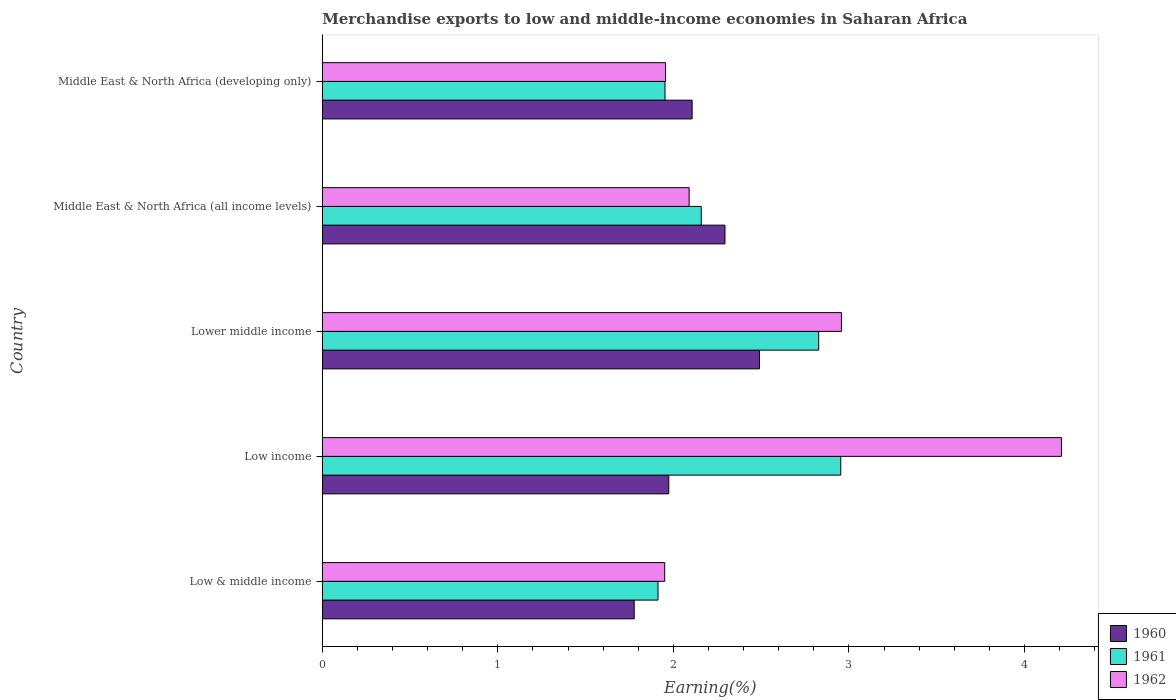How many different coloured bars are there?
Offer a very short reply. 3. Are the number of bars per tick equal to the number of legend labels?
Keep it short and to the point. Yes. Are the number of bars on each tick of the Y-axis equal?
Ensure brevity in your answer.  Yes. How many bars are there on the 5th tick from the top?
Your response must be concise. 3. What is the label of the 3rd group of bars from the top?
Ensure brevity in your answer.  Lower middle income. What is the percentage of amount earned from merchandise exports in 1960 in Middle East & North Africa (all income levels)?
Ensure brevity in your answer.  2.29. Across all countries, what is the maximum percentage of amount earned from merchandise exports in 1961?
Your answer should be very brief. 2.95. Across all countries, what is the minimum percentage of amount earned from merchandise exports in 1960?
Your answer should be very brief. 1.78. In which country was the percentage of amount earned from merchandise exports in 1961 maximum?
Provide a short and direct response. Low income. In which country was the percentage of amount earned from merchandise exports in 1962 minimum?
Provide a succinct answer. Low & middle income. What is the total percentage of amount earned from merchandise exports in 1960 in the graph?
Keep it short and to the point. 10.64. What is the difference between the percentage of amount earned from merchandise exports in 1960 in Low income and that in Middle East & North Africa (all income levels)?
Your response must be concise. -0.32. What is the difference between the percentage of amount earned from merchandise exports in 1962 in Lower middle income and the percentage of amount earned from merchandise exports in 1960 in Middle East & North Africa (developing only)?
Make the answer very short. 0.85. What is the average percentage of amount earned from merchandise exports in 1960 per country?
Make the answer very short. 2.13. What is the difference between the percentage of amount earned from merchandise exports in 1961 and percentage of amount earned from merchandise exports in 1962 in Low income?
Your answer should be very brief. -1.26. What is the ratio of the percentage of amount earned from merchandise exports in 1961 in Low income to that in Lower middle income?
Provide a short and direct response. 1.04. Is the difference between the percentage of amount earned from merchandise exports in 1961 in Middle East & North Africa (all income levels) and Middle East & North Africa (developing only) greater than the difference between the percentage of amount earned from merchandise exports in 1962 in Middle East & North Africa (all income levels) and Middle East & North Africa (developing only)?
Your answer should be compact. Yes. What is the difference between the highest and the second highest percentage of amount earned from merchandise exports in 1960?
Offer a terse response. 0.2. What is the difference between the highest and the lowest percentage of amount earned from merchandise exports in 1961?
Offer a very short reply. 1.04. In how many countries, is the percentage of amount earned from merchandise exports in 1960 greater than the average percentage of amount earned from merchandise exports in 1960 taken over all countries?
Provide a short and direct response. 2. Is the sum of the percentage of amount earned from merchandise exports in 1962 in Lower middle income and Middle East & North Africa (all income levels) greater than the maximum percentage of amount earned from merchandise exports in 1961 across all countries?
Ensure brevity in your answer.  Yes. What does the 3rd bar from the top in Middle East & North Africa (all income levels) represents?
Keep it short and to the point. 1960. What does the 3rd bar from the bottom in Middle East & North Africa (developing only) represents?
Keep it short and to the point. 1962. How many bars are there?
Provide a succinct answer. 15. What is the difference between two consecutive major ticks on the X-axis?
Your answer should be very brief. 1. How are the legend labels stacked?
Offer a terse response. Vertical. What is the title of the graph?
Give a very brief answer. Merchandise exports to low and middle-income economies in Saharan Africa. Does "1970" appear as one of the legend labels in the graph?
Provide a succinct answer. No. What is the label or title of the X-axis?
Provide a short and direct response. Earning(%). What is the label or title of the Y-axis?
Your response must be concise. Country. What is the Earning(%) of 1960 in Low & middle income?
Keep it short and to the point. 1.78. What is the Earning(%) of 1961 in Low & middle income?
Your answer should be very brief. 1.91. What is the Earning(%) of 1962 in Low & middle income?
Your response must be concise. 1.95. What is the Earning(%) in 1960 in Low income?
Ensure brevity in your answer.  1.97. What is the Earning(%) of 1961 in Low income?
Give a very brief answer. 2.95. What is the Earning(%) of 1962 in Low income?
Your response must be concise. 4.21. What is the Earning(%) in 1960 in Lower middle income?
Give a very brief answer. 2.49. What is the Earning(%) in 1961 in Lower middle income?
Give a very brief answer. 2.83. What is the Earning(%) in 1962 in Lower middle income?
Your answer should be very brief. 2.96. What is the Earning(%) in 1960 in Middle East & North Africa (all income levels)?
Keep it short and to the point. 2.29. What is the Earning(%) of 1961 in Middle East & North Africa (all income levels)?
Your answer should be very brief. 2.16. What is the Earning(%) of 1962 in Middle East & North Africa (all income levels)?
Provide a short and direct response. 2.09. What is the Earning(%) of 1960 in Middle East & North Africa (developing only)?
Give a very brief answer. 2.11. What is the Earning(%) of 1961 in Middle East & North Africa (developing only)?
Offer a terse response. 1.95. What is the Earning(%) in 1962 in Middle East & North Africa (developing only)?
Provide a succinct answer. 1.96. Across all countries, what is the maximum Earning(%) of 1960?
Give a very brief answer. 2.49. Across all countries, what is the maximum Earning(%) of 1961?
Ensure brevity in your answer.  2.95. Across all countries, what is the maximum Earning(%) of 1962?
Keep it short and to the point. 4.21. Across all countries, what is the minimum Earning(%) of 1960?
Offer a very short reply. 1.78. Across all countries, what is the minimum Earning(%) in 1961?
Keep it short and to the point. 1.91. Across all countries, what is the minimum Earning(%) in 1962?
Your answer should be very brief. 1.95. What is the total Earning(%) in 1960 in the graph?
Ensure brevity in your answer.  10.64. What is the total Earning(%) of 1961 in the graph?
Offer a terse response. 11.8. What is the total Earning(%) in 1962 in the graph?
Give a very brief answer. 13.16. What is the difference between the Earning(%) of 1960 in Low & middle income and that in Low income?
Your response must be concise. -0.2. What is the difference between the Earning(%) in 1961 in Low & middle income and that in Low income?
Provide a succinct answer. -1.04. What is the difference between the Earning(%) in 1962 in Low & middle income and that in Low income?
Offer a terse response. -2.26. What is the difference between the Earning(%) of 1960 in Low & middle income and that in Lower middle income?
Provide a succinct answer. -0.71. What is the difference between the Earning(%) of 1961 in Low & middle income and that in Lower middle income?
Give a very brief answer. -0.92. What is the difference between the Earning(%) of 1962 in Low & middle income and that in Lower middle income?
Offer a very short reply. -1.01. What is the difference between the Earning(%) in 1960 in Low & middle income and that in Middle East & North Africa (all income levels)?
Ensure brevity in your answer.  -0.52. What is the difference between the Earning(%) of 1961 in Low & middle income and that in Middle East & North Africa (all income levels)?
Make the answer very short. -0.25. What is the difference between the Earning(%) in 1962 in Low & middle income and that in Middle East & North Africa (all income levels)?
Offer a very short reply. -0.14. What is the difference between the Earning(%) in 1960 in Low & middle income and that in Middle East & North Africa (developing only)?
Offer a very short reply. -0.33. What is the difference between the Earning(%) of 1961 in Low & middle income and that in Middle East & North Africa (developing only)?
Offer a very short reply. -0.04. What is the difference between the Earning(%) in 1962 in Low & middle income and that in Middle East & North Africa (developing only)?
Your answer should be compact. -0. What is the difference between the Earning(%) in 1960 in Low income and that in Lower middle income?
Provide a short and direct response. -0.52. What is the difference between the Earning(%) in 1961 in Low income and that in Lower middle income?
Your response must be concise. 0.13. What is the difference between the Earning(%) in 1962 in Low income and that in Lower middle income?
Your answer should be very brief. 1.25. What is the difference between the Earning(%) of 1960 in Low income and that in Middle East & North Africa (all income levels)?
Your answer should be very brief. -0.32. What is the difference between the Earning(%) in 1961 in Low income and that in Middle East & North Africa (all income levels)?
Give a very brief answer. 0.79. What is the difference between the Earning(%) of 1962 in Low income and that in Middle East & North Africa (all income levels)?
Provide a succinct answer. 2.12. What is the difference between the Earning(%) of 1960 in Low income and that in Middle East & North Africa (developing only)?
Keep it short and to the point. -0.13. What is the difference between the Earning(%) of 1961 in Low income and that in Middle East & North Africa (developing only)?
Provide a succinct answer. 1. What is the difference between the Earning(%) in 1962 in Low income and that in Middle East & North Africa (developing only)?
Offer a very short reply. 2.26. What is the difference between the Earning(%) of 1960 in Lower middle income and that in Middle East & North Africa (all income levels)?
Keep it short and to the point. 0.2. What is the difference between the Earning(%) in 1961 in Lower middle income and that in Middle East & North Africa (all income levels)?
Provide a succinct answer. 0.67. What is the difference between the Earning(%) of 1962 in Lower middle income and that in Middle East & North Africa (all income levels)?
Your answer should be very brief. 0.87. What is the difference between the Earning(%) of 1960 in Lower middle income and that in Middle East & North Africa (developing only)?
Your answer should be very brief. 0.38. What is the difference between the Earning(%) of 1961 in Lower middle income and that in Middle East & North Africa (developing only)?
Offer a very short reply. 0.88. What is the difference between the Earning(%) of 1960 in Middle East & North Africa (all income levels) and that in Middle East & North Africa (developing only)?
Offer a very short reply. 0.19. What is the difference between the Earning(%) of 1961 in Middle East & North Africa (all income levels) and that in Middle East & North Africa (developing only)?
Provide a short and direct response. 0.21. What is the difference between the Earning(%) in 1962 in Middle East & North Africa (all income levels) and that in Middle East & North Africa (developing only)?
Give a very brief answer. 0.13. What is the difference between the Earning(%) of 1960 in Low & middle income and the Earning(%) of 1961 in Low income?
Make the answer very short. -1.18. What is the difference between the Earning(%) of 1960 in Low & middle income and the Earning(%) of 1962 in Low income?
Ensure brevity in your answer.  -2.43. What is the difference between the Earning(%) in 1961 in Low & middle income and the Earning(%) in 1962 in Low income?
Make the answer very short. -2.3. What is the difference between the Earning(%) in 1960 in Low & middle income and the Earning(%) in 1961 in Lower middle income?
Offer a very short reply. -1.05. What is the difference between the Earning(%) of 1960 in Low & middle income and the Earning(%) of 1962 in Lower middle income?
Ensure brevity in your answer.  -1.18. What is the difference between the Earning(%) in 1961 in Low & middle income and the Earning(%) in 1962 in Lower middle income?
Make the answer very short. -1.05. What is the difference between the Earning(%) of 1960 in Low & middle income and the Earning(%) of 1961 in Middle East & North Africa (all income levels)?
Keep it short and to the point. -0.38. What is the difference between the Earning(%) of 1960 in Low & middle income and the Earning(%) of 1962 in Middle East & North Africa (all income levels)?
Offer a very short reply. -0.31. What is the difference between the Earning(%) in 1961 in Low & middle income and the Earning(%) in 1962 in Middle East & North Africa (all income levels)?
Your response must be concise. -0.18. What is the difference between the Earning(%) of 1960 in Low & middle income and the Earning(%) of 1961 in Middle East & North Africa (developing only)?
Offer a terse response. -0.18. What is the difference between the Earning(%) of 1960 in Low & middle income and the Earning(%) of 1962 in Middle East & North Africa (developing only)?
Your answer should be very brief. -0.18. What is the difference between the Earning(%) in 1961 in Low & middle income and the Earning(%) in 1962 in Middle East & North Africa (developing only)?
Give a very brief answer. -0.04. What is the difference between the Earning(%) of 1960 in Low income and the Earning(%) of 1961 in Lower middle income?
Keep it short and to the point. -0.85. What is the difference between the Earning(%) of 1960 in Low income and the Earning(%) of 1962 in Lower middle income?
Offer a very short reply. -0.98. What is the difference between the Earning(%) in 1961 in Low income and the Earning(%) in 1962 in Lower middle income?
Make the answer very short. -0. What is the difference between the Earning(%) of 1960 in Low income and the Earning(%) of 1961 in Middle East & North Africa (all income levels)?
Make the answer very short. -0.18. What is the difference between the Earning(%) of 1960 in Low income and the Earning(%) of 1962 in Middle East & North Africa (all income levels)?
Offer a very short reply. -0.12. What is the difference between the Earning(%) of 1961 in Low income and the Earning(%) of 1962 in Middle East & North Africa (all income levels)?
Make the answer very short. 0.86. What is the difference between the Earning(%) of 1960 in Low income and the Earning(%) of 1961 in Middle East & North Africa (developing only)?
Offer a very short reply. 0.02. What is the difference between the Earning(%) in 1960 in Low income and the Earning(%) in 1962 in Middle East & North Africa (developing only)?
Keep it short and to the point. 0.02. What is the difference between the Earning(%) of 1960 in Lower middle income and the Earning(%) of 1961 in Middle East & North Africa (all income levels)?
Make the answer very short. 0.33. What is the difference between the Earning(%) in 1960 in Lower middle income and the Earning(%) in 1962 in Middle East & North Africa (all income levels)?
Ensure brevity in your answer.  0.4. What is the difference between the Earning(%) in 1961 in Lower middle income and the Earning(%) in 1962 in Middle East & North Africa (all income levels)?
Keep it short and to the point. 0.74. What is the difference between the Earning(%) of 1960 in Lower middle income and the Earning(%) of 1961 in Middle East & North Africa (developing only)?
Offer a terse response. 0.54. What is the difference between the Earning(%) in 1960 in Lower middle income and the Earning(%) in 1962 in Middle East & North Africa (developing only)?
Provide a short and direct response. 0.54. What is the difference between the Earning(%) of 1961 in Lower middle income and the Earning(%) of 1962 in Middle East & North Africa (developing only)?
Your answer should be compact. 0.87. What is the difference between the Earning(%) in 1960 in Middle East & North Africa (all income levels) and the Earning(%) in 1961 in Middle East & North Africa (developing only)?
Give a very brief answer. 0.34. What is the difference between the Earning(%) in 1960 in Middle East & North Africa (all income levels) and the Earning(%) in 1962 in Middle East & North Africa (developing only)?
Make the answer very short. 0.34. What is the difference between the Earning(%) of 1961 in Middle East & North Africa (all income levels) and the Earning(%) of 1962 in Middle East & North Africa (developing only)?
Provide a short and direct response. 0.2. What is the average Earning(%) of 1960 per country?
Your answer should be very brief. 2.13. What is the average Earning(%) of 1961 per country?
Your answer should be very brief. 2.36. What is the average Earning(%) in 1962 per country?
Offer a terse response. 2.63. What is the difference between the Earning(%) in 1960 and Earning(%) in 1961 in Low & middle income?
Keep it short and to the point. -0.14. What is the difference between the Earning(%) of 1960 and Earning(%) of 1962 in Low & middle income?
Ensure brevity in your answer.  -0.17. What is the difference between the Earning(%) in 1961 and Earning(%) in 1962 in Low & middle income?
Ensure brevity in your answer.  -0.04. What is the difference between the Earning(%) of 1960 and Earning(%) of 1961 in Low income?
Give a very brief answer. -0.98. What is the difference between the Earning(%) of 1960 and Earning(%) of 1962 in Low income?
Offer a terse response. -2.24. What is the difference between the Earning(%) in 1961 and Earning(%) in 1962 in Low income?
Your answer should be very brief. -1.26. What is the difference between the Earning(%) in 1960 and Earning(%) in 1961 in Lower middle income?
Ensure brevity in your answer.  -0.34. What is the difference between the Earning(%) of 1960 and Earning(%) of 1962 in Lower middle income?
Offer a very short reply. -0.47. What is the difference between the Earning(%) in 1961 and Earning(%) in 1962 in Lower middle income?
Provide a short and direct response. -0.13. What is the difference between the Earning(%) of 1960 and Earning(%) of 1961 in Middle East & North Africa (all income levels)?
Offer a very short reply. 0.14. What is the difference between the Earning(%) of 1960 and Earning(%) of 1962 in Middle East & North Africa (all income levels)?
Your answer should be compact. 0.2. What is the difference between the Earning(%) of 1961 and Earning(%) of 1962 in Middle East & North Africa (all income levels)?
Offer a very short reply. 0.07. What is the difference between the Earning(%) in 1960 and Earning(%) in 1961 in Middle East & North Africa (developing only)?
Offer a terse response. 0.15. What is the difference between the Earning(%) in 1960 and Earning(%) in 1962 in Middle East & North Africa (developing only)?
Keep it short and to the point. 0.15. What is the difference between the Earning(%) in 1961 and Earning(%) in 1962 in Middle East & North Africa (developing only)?
Give a very brief answer. -0. What is the ratio of the Earning(%) of 1960 in Low & middle income to that in Low income?
Your answer should be very brief. 0.9. What is the ratio of the Earning(%) of 1961 in Low & middle income to that in Low income?
Offer a very short reply. 0.65. What is the ratio of the Earning(%) in 1962 in Low & middle income to that in Low income?
Keep it short and to the point. 0.46. What is the ratio of the Earning(%) of 1960 in Low & middle income to that in Lower middle income?
Keep it short and to the point. 0.71. What is the ratio of the Earning(%) of 1961 in Low & middle income to that in Lower middle income?
Your answer should be very brief. 0.68. What is the ratio of the Earning(%) in 1962 in Low & middle income to that in Lower middle income?
Keep it short and to the point. 0.66. What is the ratio of the Earning(%) of 1960 in Low & middle income to that in Middle East & North Africa (all income levels)?
Your answer should be compact. 0.77. What is the ratio of the Earning(%) of 1961 in Low & middle income to that in Middle East & North Africa (all income levels)?
Give a very brief answer. 0.89. What is the ratio of the Earning(%) of 1962 in Low & middle income to that in Middle East & North Africa (all income levels)?
Offer a terse response. 0.93. What is the ratio of the Earning(%) of 1960 in Low & middle income to that in Middle East & North Africa (developing only)?
Provide a succinct answer. 0.84. What is the ratio of the Earning(%) in 1961 in Low & middle income to that in Middle East & North Africa (developing only)?
Provide a succinct answer. 0.98. What is the ratio of the Earning(%) of 1962 in Low & middle income to that in Middle East & North Africa (developing only)?
Provide a short and direct response. 1. What is the ratio of the Earning(%) of 1960 in Low income to that in Lower middle income?
Make the answer very short. 0.79. What is the ratio of the Earning(%) of 1961 in Low income to that in Lower middle income?
Provide a succinct answer. 1.04. What is the ratio of the Earning(%) in 1962 in Low income to that in Lower middle income?
Provide a short and direct response. 1.42. What is the ratio of the Earning(%) in 1960 in Low income to that in Middle East & North Africa (all income levels)?
Your answer should be very brief. 0.86. What is the ratio of the Earning(%) in 1961 in Low income to that in Middle East & North Africa (all income levels)?
Give a very brief answer. 1.37. What is the ratio of the Earning(%) in 1962 in Low income to that in Middle East & North Africa (all income levels)?
Keep it short and to the point. 2.02. What is the ratio of the Earning(%) in 1960 in Low income to that in Middle East & North Africa (developing only)?
Your response must be concise. 0.94. What is the ratio of the Earning(%) in 1961 in Low income to that in Middle East & North Africa (developing only)?
Your answer should be compact. 1.51. What is the ratio of the Earning(%) in 1962 in Low income to that in Middle East & North Africa (developing only)?
Your answer should be compact. 2.15. What is the ratio of the Earning(%) in 1960 in Lower middle income to that in Middle East & North Africa (all income levels)?
Your response must be concise. 1.09. What is the ratio of the Earning(%) in 1961 in Lower middle income to that in Middle East & North Africa (all income levels)?
Offer a very short reply. 1.31. What is the ratio of the Earning(%) in 1962 in Lower middle income to that in Middle East & North Africa (all income levels)?
Your answer should be compact. 1.42. What is the ratio of the Earning(%) of 1960 in Lower middle income to that in Middle East & North Africa (developing only)?
Your response must be concise. 1.18. What is the ratio of the Earning(%) in 1961 in Lower middle income to that in Middle East & North Africa (developing only)?
Provide a succinct answer. 1.45. What is the ratio of the Earning(%) of 1962 in Lower middle income to that in Middle East & North Africa (developing only)?
Your response must be concise. 1.51. What is the ratio of the Earning(%) in 1960 in Middle East & North Africa (all income levels) to that in Middle East & North Africa (developing only)?
Provide a succinct answer. 1.09. What is the ratio of the Earning(%) in 1961 in Middle East & North Africa (all income levels) to that in Middle East & North Africa (developing only)?
Your response must be concise. 1.11. What is the ratio of the Earning(%) in 1962 in Middle East & North Africa (all income levels) to that in Middle East & North Africa (developing only)?
Ensure brevity in your answer.  1.07. What is the difference between the highest and the second highest Earning(%) in 1960?
Keep it short and to the point. 0.2. What is the difference between the highest and the second highest Earning(%) of 1961?
Provide a succinct answer. 0.13. What is the difference between the highest and the second highest Earning(%) of 1962?
Your answer should be compact. 1.25. What is the difference between the highest and the lowest Earning(%) of 1960?
Provide a short and direct response. 0.71. What is the difference between the highest and the lowest Earning(%) in 1961?
Your response must be concise. 1.04. What is the difference between the highest and the lowest Earning(%) of 1962?
Your answer should be compact. 2.26. 